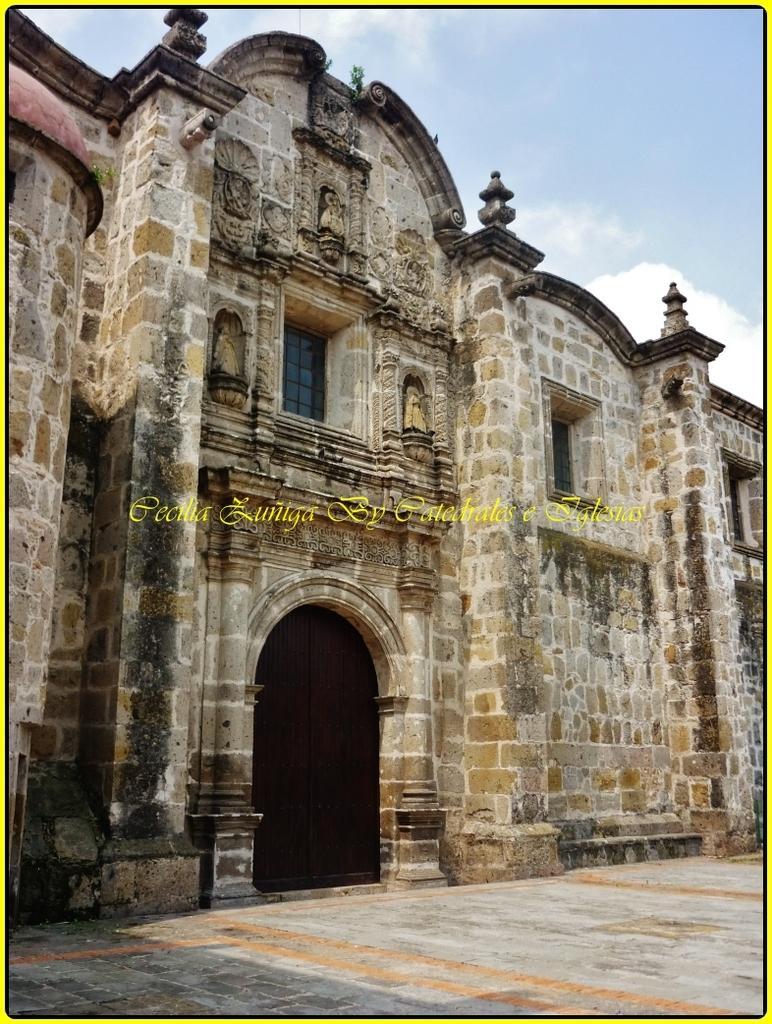In one or two sentences, can you explain what this image depicts? In this picture it looks like a monument, I can see the text in the middle. At the top there is the sky. 